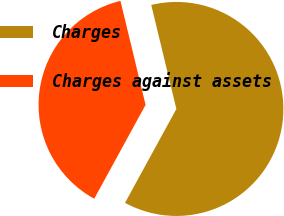Convert chart. <chart><loc_0><loc_0><loc_500><loc_500><pie_chart><fcel>Charges<fcel>Charges against assets<nl><fcel>61.74%<fcel>38.26%<nl></chart> 